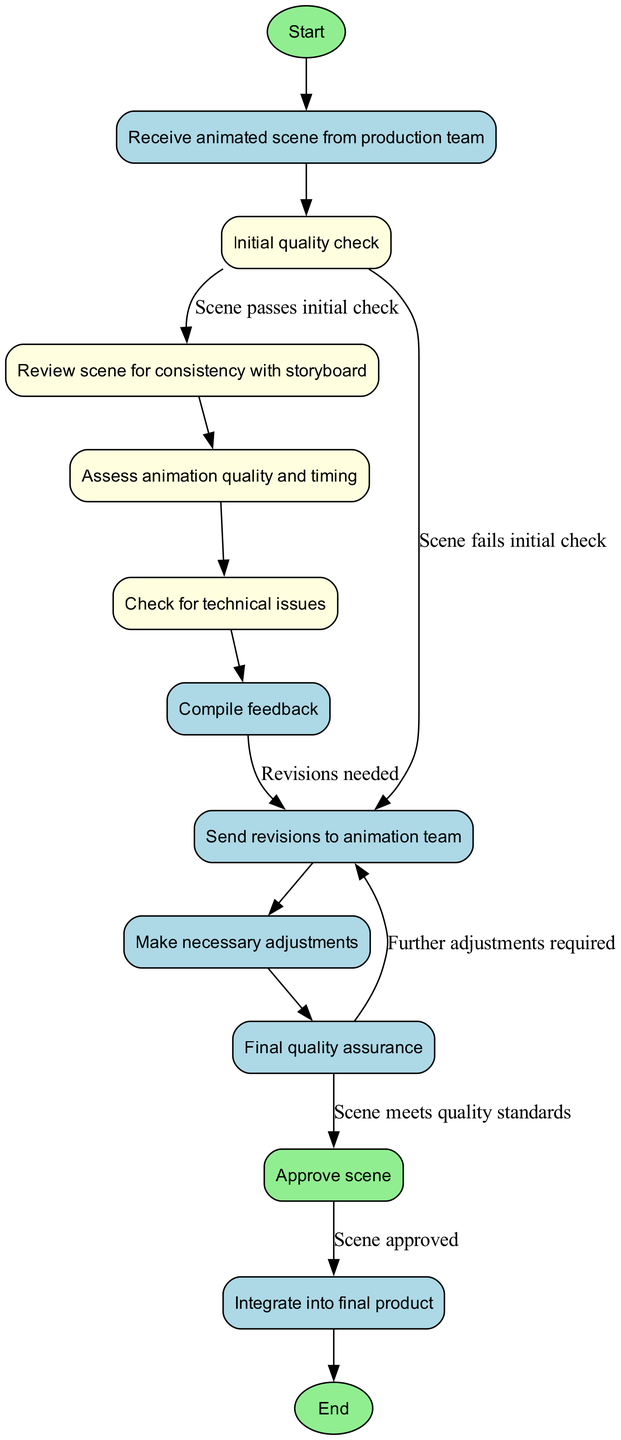What is the first node in the diagram? The first node in the diagram represents the starting point of the process and is labeled "Start".
Answer: Start How many total nodes are there in the diagram? By counting the nodes listed, there are a total of twelve nodes in the diagram that describe different stages of the quality assurance process.
Answer: 12 What does the node "Initial quality check" lead to if the scene passes? The node "Initial quality check" leads to the node "Review scene for consistency with storyboard" if the scene passes the initial check.
Answer: Review scene for consistency with storyboard What happens after "Compile feedback"? After "Compile feedback", the diagram indicates a connection to "Send revisions to animation team", which occurs if recommendations for revisions are necessary.
Answer: Send revisions to animation team If the scene needs further adjustments, which node is activated? If further adjustments are required, the process will return to "Send revisions to animation team" after "Final quality assurance" when the checks reveal additional changes needed.
Answer: Send revisions to animation team What label is associated with the edge leading from "Final quality assurance" to "Approve scene"? The edge connecting "Final quality assurance" to "Approve scene" is labeled "Scene meets quality standards", indicating the condition required for approval.
Answer: Scene meets quality standards What is the relationship between "Approve scene" and "Integrate into final product"? The relationship is that "Integrate into final product" occurs only after the "Approve scene" node is reached, indicating that the scene must be approved before integration.
Answer: Approve scene What action follows after the node "Make necessary adjustments"? The action that follows "Make necessary adjustments" is the "Final quality assurance" check, which involves ensuring quality after adjustments are made.
Answer: Final quality assurance What does the diagram indicate will occur if a scene fails the initial check? If a scene fails the initial check, the diagram indicates that it will send revisions to the animation team for further work.
Answer: Send revisions to animation team 